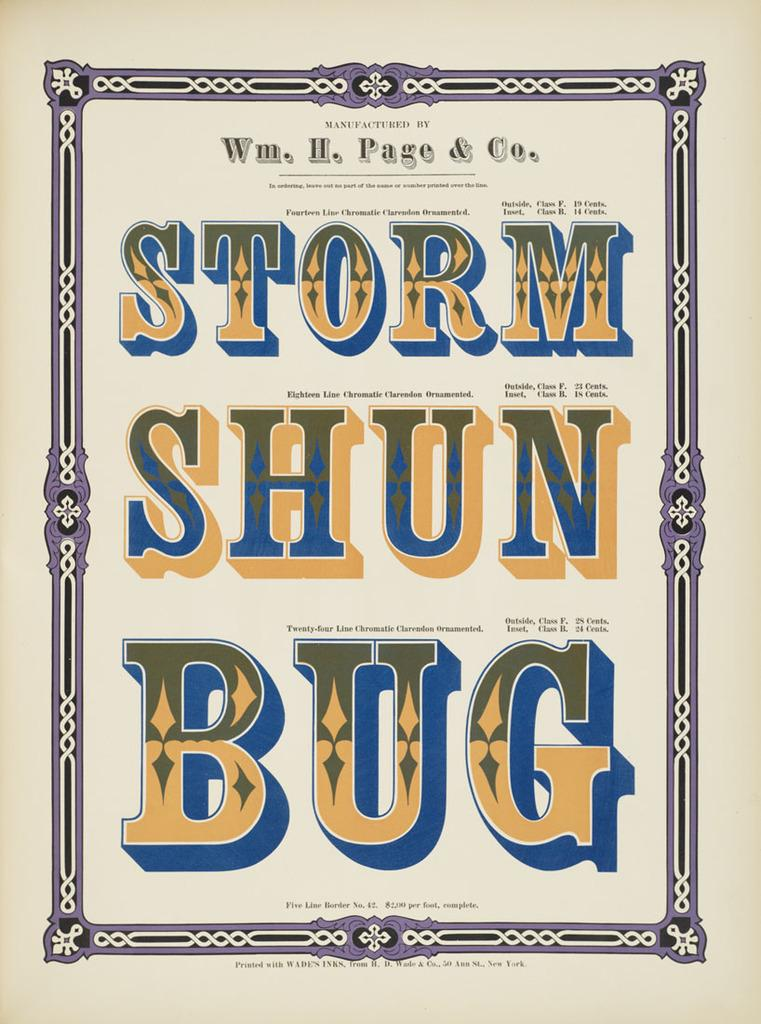What is present in the image that contains information or visuals? There is a poster in the image. What can be found on the poster besides design elements? The poster contains text. What types of visuals are present on the poster? The poster contains design elements. Where is the faucet located in the image? There is no faucet present in the image. What type of ornament is hanging from the top of the poster? There is no ornament hanging from the top of the poster in the image. 